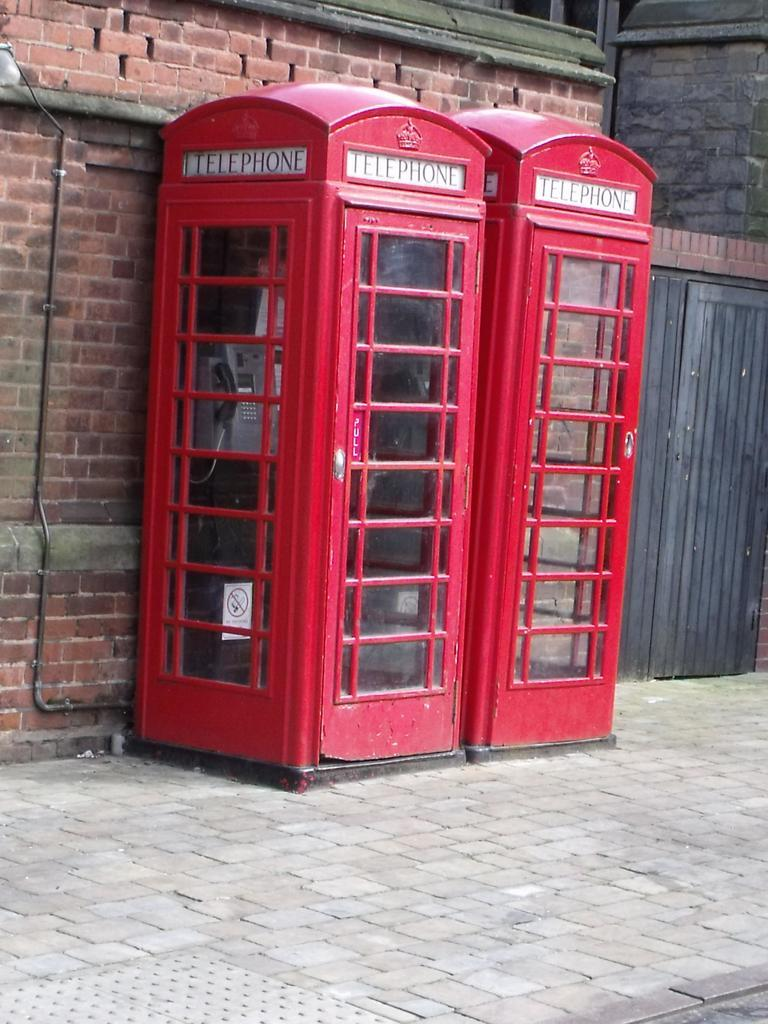<image>
Relay a brief, clear account of the picture shown. Two red phone booths that says "Telephone" on top. 